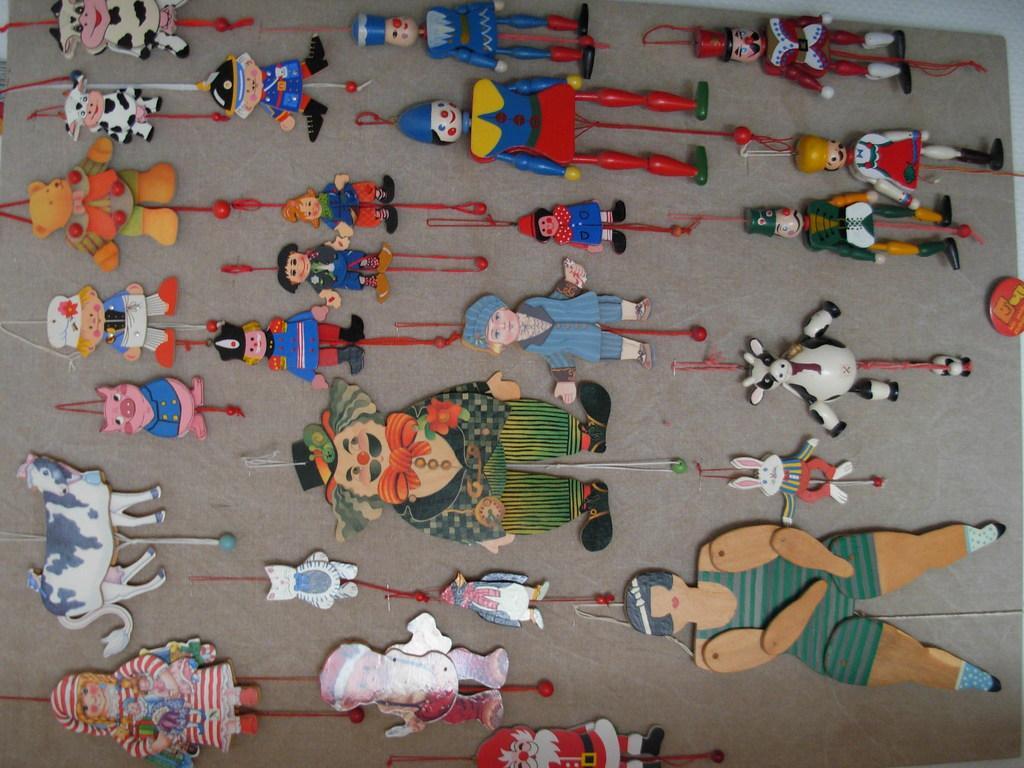Could you give a brief overview of what you see in this image? In this image we can see group of toys on a surface. Among them few are similar animal toys and human toys 